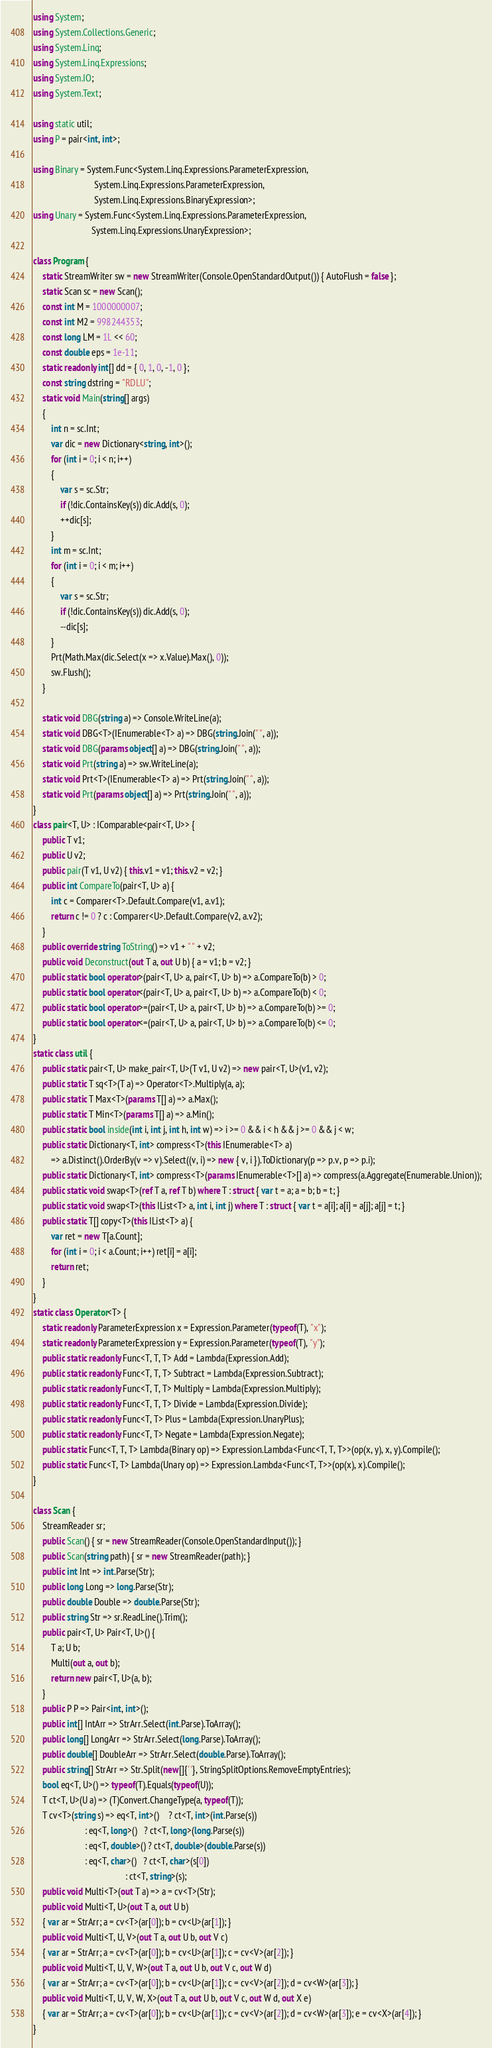<code> <loc_0><loc_0><loc_500><loc_500><_C#_>using System;
using System.Collections.Generic;
using System.Linq;
using System.Linq.Expressions;
using System.IO;
using System.Text;

using static util;
using P = pair<int, int>;

using Binary = System.Func<System.Linq.Expressions.ParameterExpression,
                           System.Linq.Expressions.ParameterExpression,
                           System.Linq.Expressions.BinaryExpression>;
using Unary = System.Func<System.Linq.Expressions.ParameterExpression,
                          System.Linq.Expressions.UnaryExpression>;

class Program {
    static StreamWriter sw = new StreamWriter(Console.OpenStandardOutput()) { AutoFlush = false };
    static Scan sc = new Scan();
    const int M = 1000000007;
    const int M2 = 998244353;
    const long LM = 1L << 60;
    const double eps = 1e-11;
    static readonly int[] dd = { 0, 1, 0, -1, 0 };
    const string dstring = "RDLU";
    static void Main(string[] args)
    {
        int n = sc.Int;
        var dic = new Dictionary<string, int>();
        for (int i = 0; i < n; i++)
        {
            var s = sc.Str;
            if (!dic.ContainsKey(s)) dic.Add(s, 0);
            ++dic[s];
        }
        int m = sc.Int;
        for (int i = 0; i < m; i++)
        {
            var s = sc.Str;
            if (!dic.ContainsKey(s)) dic.Add(s, 0);
            --dic[s];
        }
        Prt(Math.Max(dic.Select(x => x.Value).Max(), 0));
        sw.Flush();
    }

    static void DBG(string a) => Console.WriteLine(a);
    static void DBG<T>(IEnumerable<T> a) => DBG(string.Join(" ", a));
    static void DBG(params object[] a) => DBG(string.Join(" ", a));
    static void Prt(string a) => sw.WriteLine(a);
    static void Prt<T>(IEnumerable<T> a) => Prt(string.Join(" ", a));
    static void Prt(params object[] a) => Prt(string.Join(" ", a));
}
class pair<T, U> : IComparable<pair<T, U>> {
    public T v1;
    public U v2;
    public pair(T v1, U v2) { this.v1 = v1; this.v2 = v2; }
    public int CompareTo(pair<T, U> a) {
        int c = Comparer<T>.Default.Compare(v1, a.v1);
        return c != 0 ? c : Comparer<U>.Default.Compare(v2, a.v2);
    }
    public override string ToString() => v1 + " " + v2;
    public void Deconstruct(out T a, out U b) { a = v1; b = v2; }
    public static bool operator>(pair<T, U> a, pair<T, U> b) => a.CompareTo(b) > 0;
    public static bool operator<(pair<T, U> a, pair<T, U> b) => a.CompareTo(b) < 0;
    public static bool operator>=(pair<T, U> a, pair<T, U> b) => a.CompareTo(b) >= 0;
    public static bool operator<=(pair<T, U> a, pair<T, U> b) => a.CompareTo(b) <= 0;
}
static class util {
    public static pair<T, U> make_pair<T, U>(T v1, U v2) => new pair<T, U>(v1, v2);
    public static T sq<T>(T a) => Operator<T>.Multiply(a, a);
    public static T Max<T>(params T[] a) => a.Max();
    public static T Min<T>(params T[] a) => a.Min();
    public static bool inside(int i, int j, int h, int w) => i >= 0 && i < h && j >= 0 && j < w;
    public static Dictionary<T, int> compress<T>(this IEnumerable<T> a)
        => a.Distinct().OrderBy(v => v).Select((v, i) => new { v, i }).ToDictionary(p => p.v, p => p.i);
    public static Dictionary<T, int> compress<T>(params IEnumerable<T>[] a) => compress(a.Aggregate(Enumerable.Union));
    public static void swap<T>(ref T a, ref T b) where T : struct { var t = a; a = b; b = t; }
    public static void swap<T>(this IList<T> a, int i, int j) where T : struct { var t = a[i]; a[i] = a[j]; a[j] = t; }
    public static T[] copy<T>(this IList<T> a) {
        var ret = new T[a.Count];
        for (int i = 0; i < a.Count; i++) ret[i] = a[i];
        return ret;
    }
}
static class Operator<T> {
    static readonly ParameterExpression x = Expression.Parameter(typeof(T), "x");
    static readonly ParameterExpression y = Expression.Parameter(typeof(T), "y");
    public static readonly Func<T, T, T> Add = Lambda(Expression.Add);
    public static readonly Func<T, T, T> Subtract = Lambda(Expression.Subtract);
    public static readonly Func<T, T, T> Multiply = Lambda(Expression.Multiply);
    public static readonly Func<T, T, T> Divide = Lambda(Expression.Divide);
    public static readonly Func<T, T> Plus = Lambda(Expression.UnaryPlus);
    public static readonly Func<T, T> Negate = Lambda(Expression.Negate);
    public static Func<T, T, T> Lambda(Binary op) => Expression.Lambda<Func<T, T, T>>(op(x, y), x, y).Compile();
    public static Func<T, T> Lambda(Unary op) => Expression.Lambda<Func<T, T>>(op(x), x).Compile();
}

class Scan {
    StreamReader sr;
    public Scan() { sr = new StreamReader(Console.OpenStandardInput()); }
    public Scan(string path) { sr = new StreamReader(path); }
    public int Int => int.Parse(Str);
    public long Long => long.Parse(Str);
    public double Double => double.Parse(Str);
    public string Str => sr.ReadLine().Trim();
    public pair<T, U> Pair<T, U>() {
        T a; U b;
        Multi(out a, out b);
        return new pair<T, U>(a, b);
    }
    public P P => Pair<int, int>();
    public int[] IntArr => StrArr.Select(int.Parse).ToArray();
    public long[] LongArr => StrArr.Select(long.Parse).ToArray();
    public double[] DoubleArr => StrArr.Select(double.Parse).ToArray();
    public string[] StrArr => Str.Split(new[]{' '}, StringSplitOptions.RemoveEmptyEntries);
    bool eq<T, U>() => typeof(T).Equals(typeof(U));
    T ct<T, U>(U a) => (T)Convert.ChangeType(a, typeof(T));
    T cv<T>(string s) => eq<T, int>()    ? ct<T, int>(int.Parse(s))
                       : eq<T, long>()   ? ct<T, long>(long.Parse(s))
                       : eq<T, double>() ? ct<T, double>(double.Parse(s))
                       : eq<T, char>()   ? ct<T, char>(s[0])
                                         : ct<T, string>(s);
    public void Multi<T>(out T a) => a = cv<T>(Str);
    public void Multi<T, U>(out T a, out U b)
    { var ar = StrArr; a = cv<T>(ar[0]); b = cv<U>(ar[1]); }
    public void Multi<T, U, V>(out T a, out U b, out V c)
    { var ar = StrArr; a = cv<T>(ar[0]); b = cv<U>(ar[1]); c = cv<V>(ar[2]); }
    public void Multi<T, U, V, W>(out T a, out U b, out V c, out W d)
    { var ar = StrArr; a = cv<T>(ar[0]); b = cv<U>(ar[1]); c = cv<V>(ar[2]); d = cv<W>(ar[3]); }
    public void Multi<T, U, V, W, X>(out T a, out U b, out V c, out W d, out X e)
    { var ar = StrArr; a = cv<T>(ar[0]); b = cv<U>(ar[1]); c = cv<V>(ar[2]); d = cv<W>(ar[3]); e = cv<X>(ar[4]); }
}
</code> 